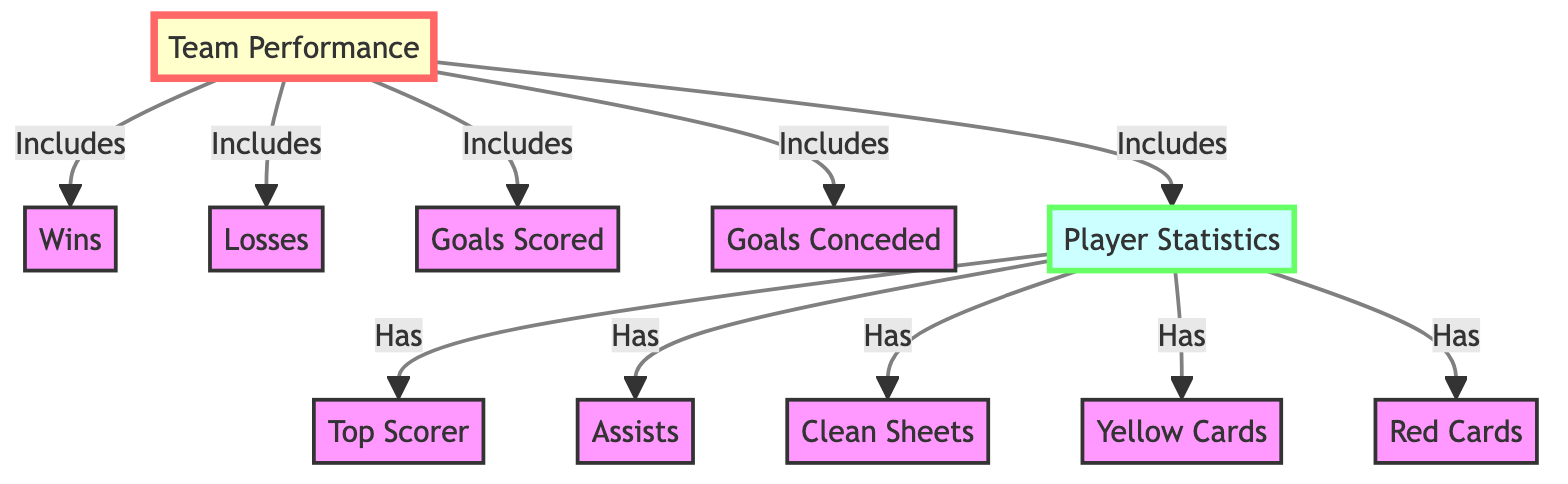What is included in the "Team Performance" summary? The "Team Performance" summary includes five metrics: Wins, Losses, Goals Scored, Goals Conceded, and Player Statistics. These metrics are directly connected to the "Team Performance" node.
Answer: Wins, Losses, Goals Scored, Goals Conceded, Player Statistics How many player statistics are listed in the diagram? There are five player statistics listed: Top Scorer, Assists, Clean Sheets, Yellow Cards, and Red Cards. This can be determined by counting the nodes connected to the "Player Statistics" node.
Answer: 5 What does the "Player Statistics" node have? The "Player Statistics" node has five components: Top Scorer, Assists, Clean Sheets, Yellow Cards, and Red Cards. Each of these is directly linked from the "Player Statistics" node, indicating they belong to this category.
Answer: Top Scorer, Assists, Clean Sheets, Yellow Cards, Red Cards Which metric indicates the number of goals a team has prevented? The "Goals Conceded" metric indicates the number of goals that a team has allowed opposing teams to score. This is a common metric in team performance analysis.
Answer: Goals Conceded What is the relationship between "Team Performance" and "Player Statistics"? The relationship is that "Player Statistics" is a component of the "Team Performance". The arrow from "Team Performance" to "Player Statistics" indicates that player statistics are included in the team's overall performance analysis.
Answer: Includes 